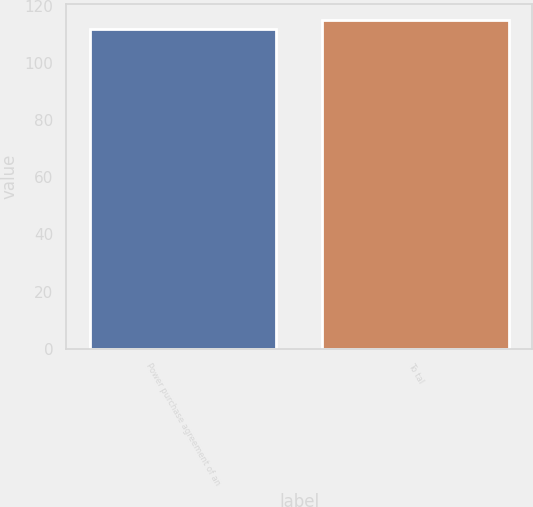Convert chart to OTSL. <chart><loc_0><loc_0><loc_500><loc_500><bar_chart><fcel>Power purchase agreement of an<fcel>To tal<nl><fcel>112<fcel>115<nl></chart> 